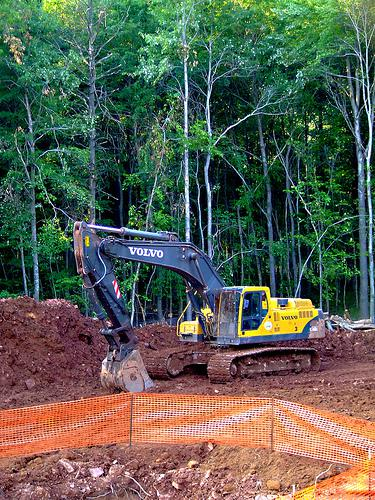Question: what brand is the vehicle?
Choices:
A. Honda.
B. Toyota.
C. Jeep.
D. Volvo.
Answer with the letter. Answer: D Question: what number is on the vehicle?
Choices:
A. 1.
B. 4.
C. 2.
D. 3.
Answer with the letter. Answer: D Question: what is the vehicle doing?
Choices:
A. Hauling trash.
B. It is parked.
C. Scooping dirt.
D. Racing.
Answer with the letter. Answer: C Question: how many times does Volvo appear on the vehicle?
Choices:
A. Three.
B. Twice.
C. One.
D. Four.
Answer with the letter. Answer: B 